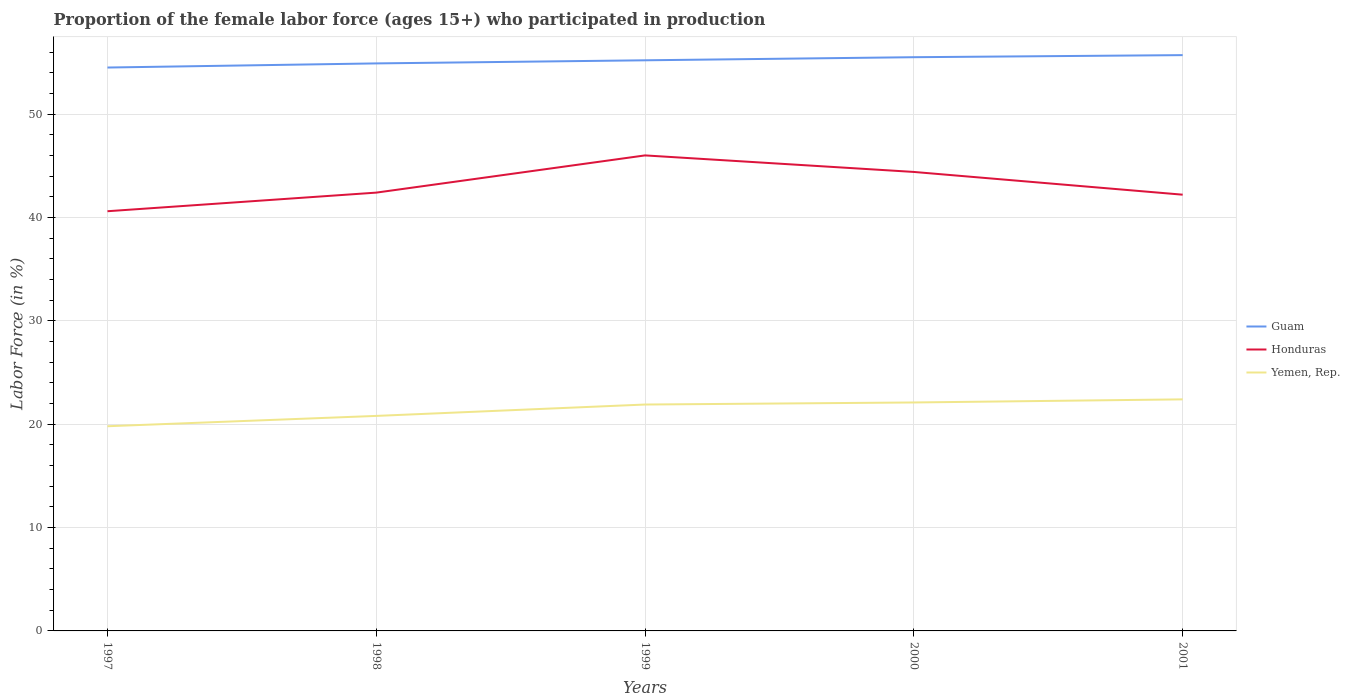How many different coloured lines are there?
Make the answer very short. 3. Does the line corresponding to Yemen, Rep. intersect with the line corresponding to Guam?
Your answer should be compact. No. Is the number of lines equal to the number of legend labels?
Offer a very short reply. Yes. Across all years, what is the maximum proportion of the female labor force who participated in production in Guam?
Ensure brevity in your answer.  54.5. What is the total proportion of the female labor force who participated in production in Guam in the graph?
Provide a short and direct response. -0.7. What is the difference between the highest and the second highest proportion of the female labor force who participated in production in Honduras?
Offer a terse response. 5.4. What is the difference between the highest and the lowest proportion of the female labor force who participated in production in Yemen, Rep.?
Your answer should be very brief. 3. Is the proportion of the female labor force who participated in production in Yemen, Rep. strictly greater than the proportion of the female labor force who participated in production in Honduras over the years?
Provide a short and direct response. Yes. How many lines are there?
Ensure brevity in your answer.  3. Does the graph contain any zero values?
Provide a succinct answer. No. Does the graph contain grids?
Your answer should be compact. Yes. What is the title of the graph?
Your response must be concise. Proportion of the female labor force (ages 15+) who participated in production. What is the label or title of the X-axis?
Your answer should be very brief. Years. What is the label or title of the Y-axis?
Provide a short and direct response. Labor Force (in %). What is the Labor Force (in %) of Guam in 1997?
Keep it short and to the point. 54.5. What is the Labor Force (in %) in Honduras in 1997?
Provide a short and direct response. 40.6. What is the Labor Force (in %) in Yemen, Rep. in 1997?
Give a very brief answer. 19.8. What is the Labor Force (in %) in Guam in 1998?
Provide a succinct answer. 54.9. What is the Labor Force (in %) in Honduras in 1998?
Keep it short and to the point. 42.4. What is the Labor Force (in %) of Yemen, Rep. in 1998?
Keep it short and to the point. 20.8. What is the Labor Force (in %) in Guam in 1999?
Give a very brief answer. 55.2. What is the Labor Force (in %) in Honduras in 1999?
Offer a very short reply. 46. What is the Labor Force (in %) of Yemen, Rep. in 1999?
Ensure brevity in your answer.  21.9. What is the Labor Force (in %) in Guam in 2000?
Offer a terse response. 55.5. What is the Labor Force (in %) in Honduras in 2000?
Your response must be concise. 44.4. What is the Labor Force (in %) in Yemen, Rep. in 2000?
Ensure brevity in your answer.  22.1. What is the Labor Force (in %) of Guam in 2001?
Your response must be concise. 55.7. What is the Labor Force (in %) in Honduras in 2001?
Keep it short and to the point. 42.2. What is the Labor Force (in %) in Yemen, Rep. in 2001?
Your answer should be very brief. 22.4. Across all years, what is the maximum Labor Force (in %) in Guam?
Provide a succinct answer. 55.7. Across all years, what is the maximum Labor Force (in %) in Honduras?
Provide a short and direct response. 46. Across all years, what is the maximum Labor Force (in %) in Yemen, Rep.?
Provide a succinct answer. 22.4. Across all years, what is the minimum Labor Force (in %) of Guam?
Give a very brief answer. 54.5. Across all years, what is the minimum Labor Force (in %) in Honduras?
Your answer should be very brief. 40.6. Across all years, what is the minimum Labor Force (in %) in Yemen, Rep.?
Your answer should be very brief. 19.8. What is the total Labor Force (in %) of Guam in the graph?
Give a very brief answer. 275.8. What is the total Labor Force (in %) in Honduras in the graph?
Offer a terse response. 215.6. What is the total Labor Force (in %) in Yemen, Rep. in the graph?
Provide a succinct answer. 107. What is the difference between the Labor Force (in %) of Guam in 1997 and that in 1998?
Ensure brevity in your answer.  -0.4. What is the difference between the Labor Force (in %) of Honduras in 1997 and that in 1998?
Provide a succinct answer. -1.8. What is the difference between the Labor Force (in %) in Yemen, Rep. in 1997 and that in 1998?
Provide a short and direct response. -1. What is the difference between the Labor Force (in %) in Guam in 1997 and that in 2000?
Provide a succinct answer. -1. What is the difference between the Labor Force (in %) of Honduras in 1997 and that in 2000?
Give a very brief answer. -3.8. What is the difference between the Labor Force (in %) of Yemen, Rep. in 1997 and that in 2000?
Keep it short and to the point. -2.3. What is the difference between the Labor Force (in %) of Honduras in 1997 and that in 2001?
Give a very brief answer. -1.6. What is the difference between the Labor Force (in %) in Guam in 1998 and that in 1999?
Your answer should be compact. -0.3. What is the difference between the Labor Force (in %) of Yemen, Rep. in 1998 and that in 1999?
Give a very brief answer. -1.1. What is the difference between the Labor Force (in %) of Honduras in 1998 and that in 2000?
Give a very brief answer. -2. What is the difference between the Labor Force (in %) in Yemen, Rep. in 1998 and that in 2000?
Keep it short and to the point. -1.3. What is the difference between the Labor Force (in %) of Guam in 1998 and that in 2001?
Ensure brevity in your answer.  -0.8. What is the difference between the Labor Force (in %) of Yemen, Rep. in 1998 and that in 2001?
Ensure brevity in your answer.  -1.6. What is the difference between the Labor Force (in %) in Honduras in 1999 and that in 2000?
Ensure brevity in your answer.  1.6. What is the difference between the Labor Force (in %) of Yemen, Rep. in 1999 and that in 2000?
Offer a very short reply. -0.2. What is the difference between the Labor Force (in %) in Honduras in 1999 and that in 2001?
Offer a terse response. 3.8. What is the difference between the Labor Force (in %) of Yemen, Rep. in 1999 and that in 2001?
Offer a very short reply. -0.5. What is the difference between the Labor Force (in %) in Yemen, Rep. in 2000 and that in 2001?
Provide a short and direct response. -0.3. What is the difference between the Labor Force (in %) in Guam in 1997 and the Labor Force (in %) in Yemen, Rep. in 1998?
Provide a short and direct response. 33.7. What is the difference between the Labor Force (in %) in Honduras in 1997 and the Labor Force (in %) in Yemen, Rep. in 1998?
Provide a succinct answer. 19.8. What is the difference between the Labor Force (in %) of Guam in 1997 and the Labor Force (in %) of Yemen, Rep. in 1999?
Give a very brief answer. 32.6. What is the difference between the Labor Force (in %) in Honduras in 1997 and the Labor Force (in %) in Yemen, Rep. in 1999?
Make the answer very short. 18.7. What is the difference between the Labor Force (in %) in Guam in 1997 and the Labor Force (in %) in Yemen, Rep. in 2000?
Offer a very short reply. 32.4. What is the difference between the Labor Force (in %) in Guam in 1997 and the Labor Force (in %) in Yemen, Rep. in 2001?
Keep it short and to the point. 32.1. What is the difference between the Labor Force (in %) of Honduras in 1997 and the Labor Force (in %) of Yemen, Rep. in 2001?
Your answer should be compact. 18.2. What is the difference between the Labor Force (in %) of Honduras in 1998 and the Labor Force (in %) of Yemen, Rep. in 1999?
Ensure brevity in your answer.  20.5. What is the difference between the Labor Force (in %) in Guam in 1998 and the Labor Force (in %) in Honduras in 2000?
Make the answer very short. 10.5. What is the difference between the Labor Force (in %) of Guam in 1998 and the Labor Force (in %) of Yemen, Rep. in 2000?
Give a very brief answer. 32.8. What is the difference between the Labor Force (in %) in Honduras in 1998 and the Labor Force (in %) in Yemen, Rep. in 2000?
Your response must be concise. 20.3. What is the difference between the Labor Force (in %) of Guam in 1998 and the Labor Force (in %) of Yemen, Rep. in 2001?
Provide a short and direct response. 32.5. What is the difference between the Labor Force (in %) in Honduras in 1998 and the Labor Force (in %) in Yemen, Rep. in 2001?
Your answer should be very brief. 20. What is the difference between the Labor Force (in %) of Guam in 1999 and the Labor Force (in %) of Honduras in 2000?
Your response must be concise. 10.8. What is the difference between the Labor Force (in %) in Guam in 1999 and the Labor Force (in %) in Yemen, Rep. in 2000?
Your answer should be compact. 33.1. What is the difference between the Labor Force (in %) in Honduras in 1999 and the Labor Force (in %) in Yemen, Rep. in 2000?
Your answer should be very brief. 23.9. What is the difference between the Labor Force (in %) in Guam in 1999 and the Labor Force (in %) in Yemen, Rep. in 2001?
Ensure brevity in your answer.  32.8. What is the difference between the Labor Force (in %) in Honduras in 1999 and the Labor Force (in %) in Yemen, Rep. in 2001?
Your answer should be very brief. 23.6. What is the difference between the Labor Force (in %) in Guam in 2000 and the Labor Force (in %) in Honduras in 2001?
Offer a very short reply. 13.3. What is the difference between the Labor Force (in %) in Guam in 2000 and the Labor Force (in %) in Yemen, Rep. in 2001?
Ensure brevity in your answer.  33.1. What is the average Labor Force (in %) in Guam per year?
Keep it short and to the point. 55.16. What is the average Labor Force (in %) in Honduras per year?
Your answer should be compact. 43.12. What is the average Labor Force (in %) of Yemen, Rep. per year?
Offer a very short reply. 21.4. In the year 1997, what is the difference between the Labor Force (in %) in Guam and Labor Force (in %) in Honduras?
Your answer should be compact. 13.9. In the year 1997, what is the difference between the Labor Force (in %) in Guam and Labor Force (in %) in Yemen, Rep.?
Your answer should be compact. 34.7. In the year 1997, what is the difference between the Labor Force (in %) of Honduras and Labor Force (in %) of Yemen, Rep.?
Provide a succinct answer. 20.8. In the year 1998, what is the difference between the Labor Force (in %) in Guam and Labor Force (in %) in Honduras?
Provide a short and direct response. 12.5. In the year 1998, what is the difference between the Labor Force (in %) in Guam and Labor Force (in %) in Yemen, Rep.?
Offer a terse response. 34.1. In the year 1998, what is the difference between the Labor Force (in %) in Honduras and Labor Force (in %) in Yemen, Rep.?
Provide a succinct answer. 21.6. In the year 1999, what is the difference between the Labor Force (in %) of Guam and Labor Force (in %) of Yemen, Rep.?
Provide a succinct answer. 33.3. In the year 1999, what is the difference between the Labor Force (in %) of Honduras and Labor Force (in %) of Yemen, Rep.?
Your answer should be very brief. 24.1. In the year 2000, what is the difference between the Labor Force (in %) of Guam and Labor Force (in %) of Honduras?
Ensure brevity in your answer.  11.1. In the year 2000, what is the difference between the Labor Force (in %) of Guam and Labor Force (in %) of Yemen, Rep.?
Give a very brief answer. 33.4. In the year 2000, what is the difference between the Labor Force (in %) in Honduras and Labor Force (in %) in Yemen, Rep.?
Your response must be concise. 22.3. In the year 2001, what is the difference between the Labor Force (in %) of Guam and Labor Force (in %) of Honduras?
Make the answer very short. 13.5. In the year 2001, what is the difference between the Labor Force (in %) in Guam and Labor Force (in %) in Yemen, Rep.?
Provide a succinct answer. 33.3. In the year 2001, what is the difference between the Labor Force (in %) in Honduras and Labor Force (in %) in Yemen, Rep.?
Give a very brief answer. 19.8. What is the ratio of the Labor Force (in %) of Guam in 1997 to that in 1998?
Ensure brevity in your answer.  0.99. What is the ratio of the Labor Force (in %) of Honduras in 1997 to that in 1998?
Give a very brief answer. 0.96. What is the ratio of the Labor Force (in %) of Yemen, Rep. in 1997 to that in 1998?
Give a very brief answer. 0.95. What is the ratio of the Labor Force (in %) of Guam in 1997 to that in 1999?
Give a very brief answer. 0.99. What is the ratio of the Labor Force (in %) in Honduras in 1997 to that in 1999?
Make the answer very short. 0.88. What is the ratio of the Labor Force (in %) in Yemen, Rep. in 1997 to that in 1999?
Your answer should be very brief. 0.9. What is the ratio of the Labor Force (in %) of Guam in 1997 to that in 2000?
Your answer should be very brief. 0.98. What is the ratio of the Labor Force (in %) in Honduras in 1997 to that in 2000?
Your response must be concise. 0.91. What is the ratio of the Labor Force (in %) of Yemen, Rep. in 1997 to that in 2000?
Your response must be concise. 0.9. What is the ratio of the Labor Force (in %) of Guam in 1997 to that in 2001?
Your answer should be very brief. 0.98. What is the ratio of the Labor Force (in %) of Honduras in 1997 to that in 2001?
Your answer should be compact. 0.96. What is the ratio of the Labor Force (in %) in Yemen, Rep. in 1997 to that in 2001?
Keep it short and to the point. 0.88. What is the ratio of the Labor Force (in %) of Guam in 1998 to that in 1999?
Offer a terse response. 0.99. What is the ratio of the Labor Force (in %) of Honduras in 1998 to that in 1999?
Ensure brevity in your answer.  0.92. What is the ratio of the Labor Force (in %) of Yemen, Rep. in 1998 to that in 1999?
Provide a short and direct response. 0.95. What is the ratio of the Labor Force (in %) of Guam in 1998 to that in 2000?
Provide a short and direct response. 0.99. What is the ratio of the Labor Force (in %) in Honduras in 1998 to that in 2000?
Ensure brevity in your answer.  0.95. What is the ratio of the Labor Force (in %) of Yemen, Rep. in 1998 to that in 2000?
Keep it short and to the point. 0.94. What is the ratio of the Labor Force (in %) of Guam in 1998 to that in 2001?
Offer a very short reply. 0.99. What is the ratio of the Labor Force (in %) of Guam in 1999 to that in 2000?
Offer a terse response. 0.99. What is the ratio of the Labor Force (in %) of Honduras in 1999 to that in 2000?
Keep it short and to the point. 1.04. What is the ratio of the Labor Force (in %) in Honduras in 1999 to that in 2001?
Keep it short and to the point. 1.09. What is the ratio of the Labor Force (in %) in Yemen, Rep. in 1999 to that in 2001?
Your answer should be very brief. 0.98. What is the ratio of the Labor Force (in %) in Guam in 2000 to that in 2001?
Your answer should be very brief. 1. What is the ratio of the Labor Force (in %) in Honduras in 2000 to that in 2001?
Keep it short and to the point. 1.05. What is the ratio of the Labor Force (in %) of Yemen, Rep. in 2000 to that in 2001?
Keep it short and to the point. 0.99. What is the difference between the highest and the second highest Labor Force (in %) in Guam?
Give a very brief answer. 0.2. What is the difference between the highest and the second highest Labor Force (in %) of Honduras?
Your answer should be compact. 1.6. What is the difference between the highest and the second highest Labor Force (in %) in Yemen, Rep.?
Your response must be concise. 0.3. 